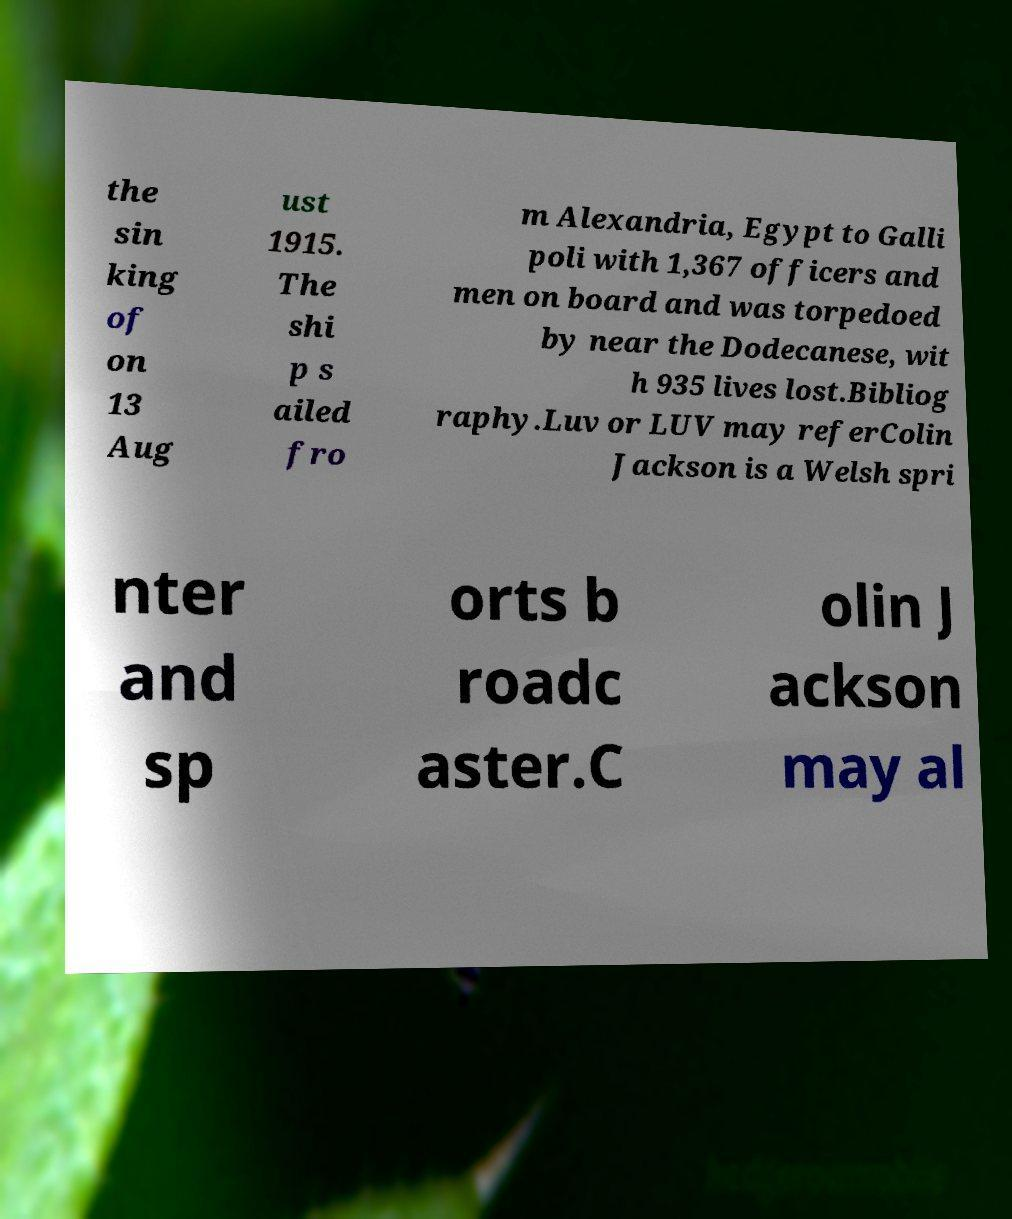For documentation purposes, I need the text within this image transcribed. Could you provide that? the sin king of on 13 Aug ust 1915. The shi p s ailed fro m Alexandria, Egypt to Galli poli with 1,367 officers and men on board and was torpedoed by near the Dodecanese, wit h 935 lives lost.Bibliog raphy.Luv or LUV may referColin Jackson is a Welsh spri nter and sp orts b roadc aster.C olin J ackson may al 